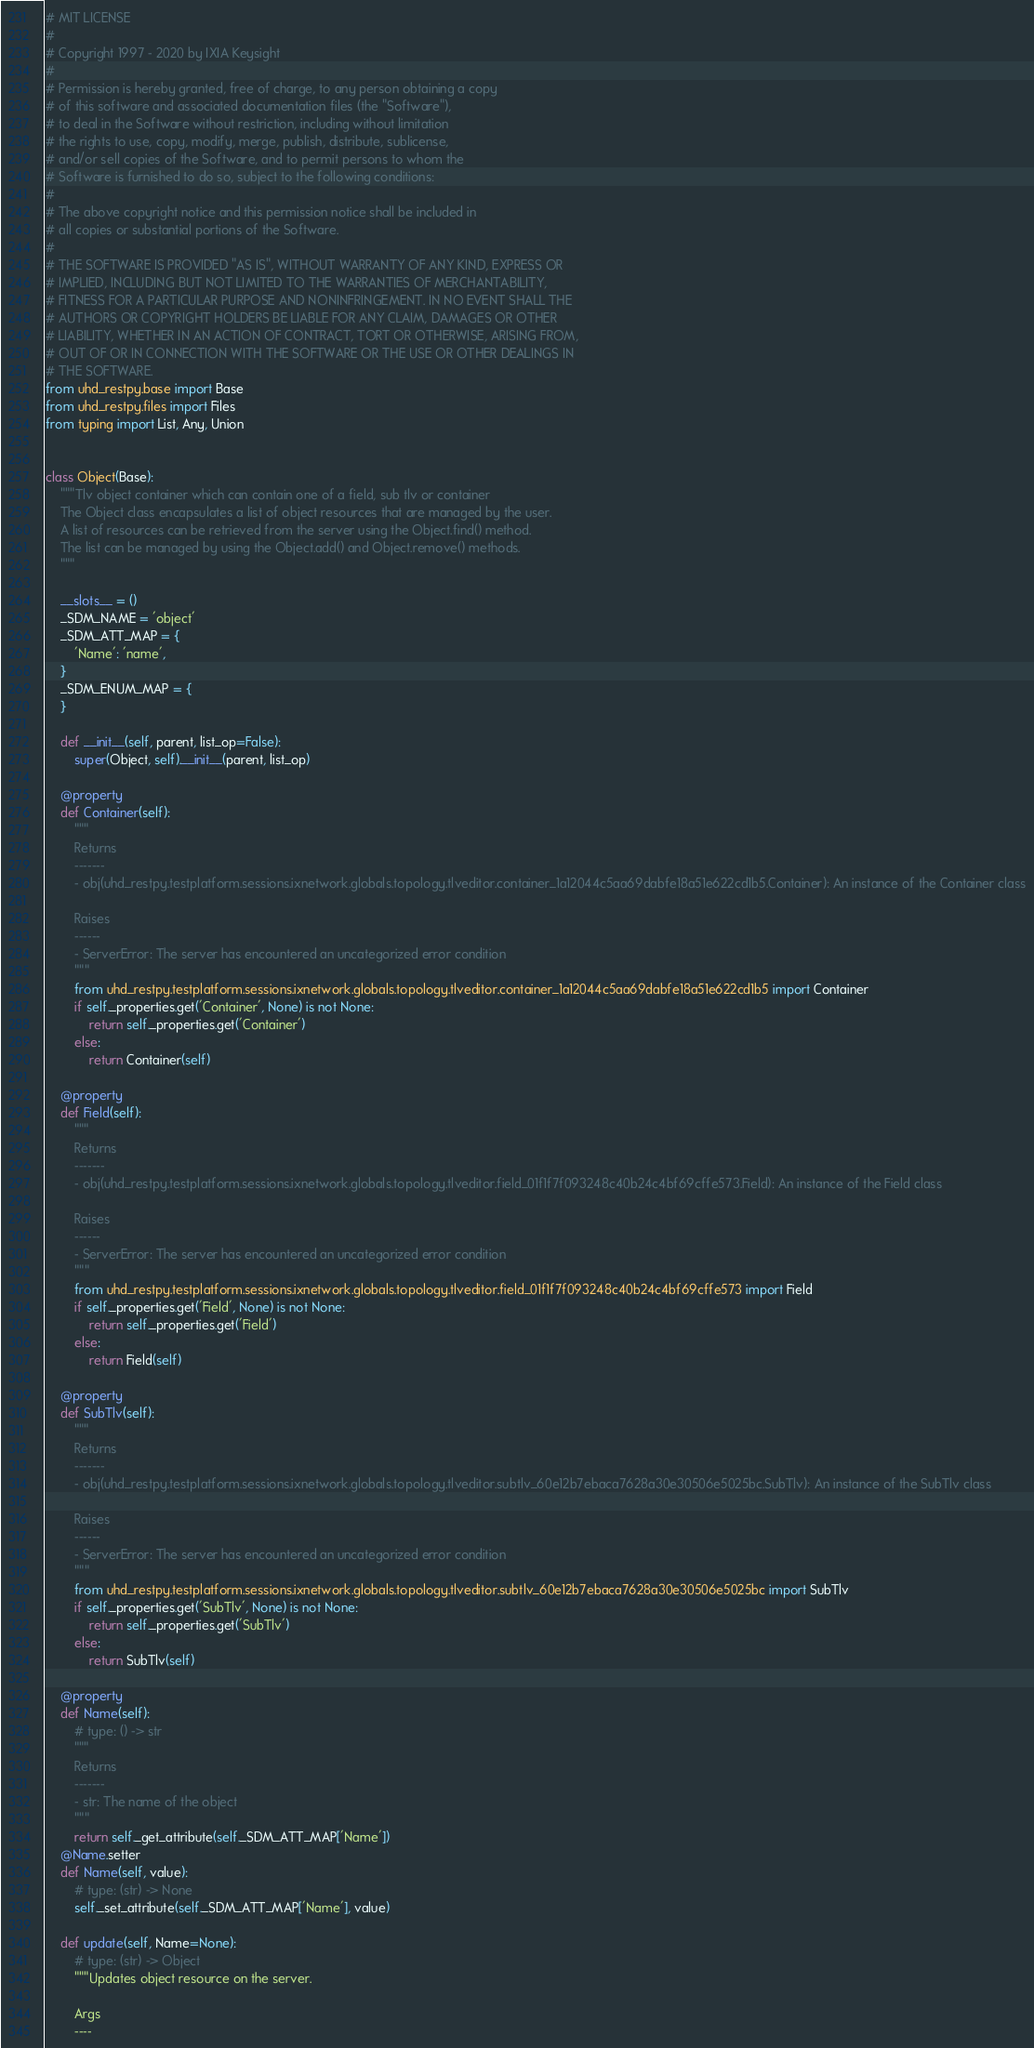Convert code to text. <code><loc_0><loc_0><loc_500><loc_500><_Python_># MIT LICENSE
#
# Copyright 1997 - 2020 by IXIA Keysight
#
# Permission is hereby granted, free of charge, to any person obtaining a copy
# of this software and associated documentation files (the "Software"),
# to deal in the Software without restriction, including without limitation
# the rights to use, copy, modify, merge, publish, distribute, sublicense,
# and/or sell copies of the Software, and to permit persons to whom the
# Software is furnished to do so, subject to the following conditions:
#
# The above copyright notice and this permission notice shall be included in
# all copies or substantial portions of the Software.
#
# THE SOFTWARE IS PROVIDED "AS IS", WITHOUT WARRANTY OF ANY KIND, EXPRESS OR
# IMPLIED, INCLUDING BUT NOT LIMITED TO THE WARRANTIES OF MERCHANTABILITY,
# FITNESS FOR A PARTICULAR PURPOSE AND NONINFRINGEMENT. IN NO EVENT SHALL THE
# AUTHORS OR COPYRIGHT HOLDERS BE LIABLE FOR ANY CLAIM, DAMAGES OR OTHER
# LIABILITY, WHETHER IN AN ACTION OF CONTRACT, TORT OR OTHERWISE, ARISING FROM,
# OUT OF OR IN CONNECTION WITH THE SOFTWARE OR THE USE OR OTHER DEALINGS IN
# THE SOFTWARE. 
from uhd_restpy.base import Base
from uhd_restpy.files import Files
from typing import List, Any, Union


class Object(Base):
    """Tlv object container which can contain one of a field, sub tlv or container
    The Object class encapsulates a list of object resources that are managed by the user.
    A list of resources can be retrieved from the server using the Object.find() method.
    The list can be managed by using the Object.add() and Object.remove() methods.
    """

    __slots__ = ()
    _SDM_NAME = 'object'
    _SDM_ATT_MAP = {
        'Name': 'name',
    }
    _SDM_ENUM_MAP = {
    }

    def __init__(self, parent, list_op=False):
        super(Object, self).__init__(parent, list_op)

    @property
    def Container(self):
        """
        Returns
        -------
        - obj(uhd_restpy.testplatform.sessions.ixnetwork.globals.topology.tlveditor.container_1a12044c5aa69dabfe18a51e622cd1b5.Container): An instance of the Container class

        Raises
        ------
        - ServerError: The server has encountered an uncategorized error condition
        """
        from uhd_restpy.testplatform.sessions.ixnetwork.globals.topology.tlveditor.container_1a12044c5aa69dabfe18a51e622cd1b5 import Container
        if self._properties.get('Container', None) is not None:
            return self._properties.get('Container')
        else:
            return Container(self)

    @property
    def Field(self):
        """
        Returns
        -------
        - obj(uhd_restpy.testplatform.sessions.ixnetwork.globals.topology.tlveditor.field_01f1f7f093248c40b24c4bf69cffe573.Field): An instance of the Field class

        Raises
        ------
        - ServerError: The server has encountered an uncategorized error condition
        """
        from uhd_restpy.testplatform.sessions.ixnetwork.globals.topology.tlveditor.field_01f1f7f093248c40b24c4bf69cffe573 import Field
        if self._properties.get('Field', None) is not None:
            return self._properties.get('Field')
        else:
            return Field(self)

    @property
    def SubTlv(self):
        """
        Returns
        -------
        - obj(uhd_restpy.testplatform.sessions.ixnetwork.globals.topology.tlveditor.subtlv_60e12b7ebaca7628a30e30506e5025bc.SubTlv): An instance of the SubTlv class

        Raises
        ------
        - ServerError: The server has encountered an uncategorized error condition
        """
        from uhd_restpy.testplatform.sessions.ixnetwork.globals.topology.tlveditor.subtlv_60e12b7ebaca7628a30e30506e5025bc import SubTlv
        if self._properties.get('SubTlv', None) is not None:
            return self._properties.get('SubTlv')
        else:
            return SubTlv(self)

    @property
    def Name(self):
        # type: () -> str
        """
        Returns
        -------
        - str: The name of the object
        """
        return self._get_attribute(self._SDM_ATT_MAP['Name'])
    @Name.setter
    def Name(self, value):
        # type: (str) -> None
        self._set_attribute(self._SDM_ATT_MAP['Name'], value)

    def update(self, Name=None):
        # type: (str) -> Object
        """Updates object resource on the server.

        Args
        ----</code> 